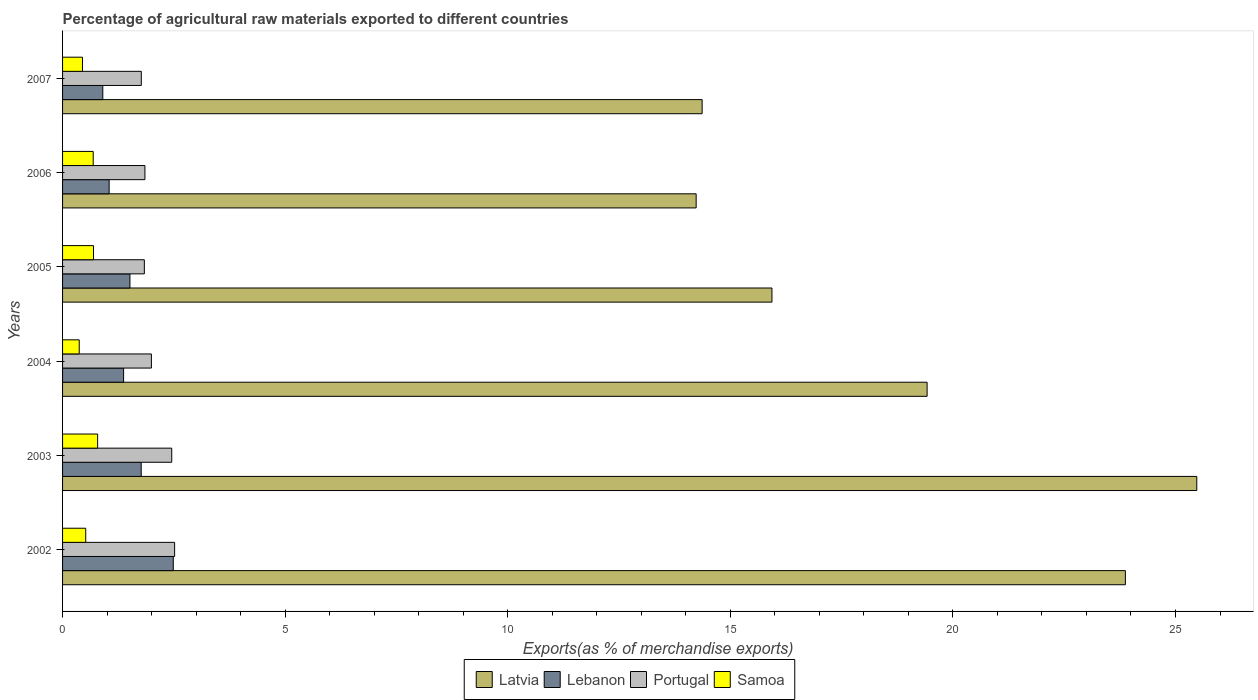How many groups of bars are there?
Your response must be concise. 6. Are the number of bars per tick equal to the number of legend labels?
Provide a succinct answer. Yes. Are the number of bars on each tick of the Y-axis equal?
Make the answer very short. Yes. How many bars are there on the 6th tick from the top?
Your answer should be compact. 4. In how many cases, is the number of bars for a given year not equal to the number of legend labels?
Provide a succinct answer. 0. What is the percentage of exports to different countries in Latvia in 2003?
Offer a terse response. 25.48. Across all years, what is the maximum percentage of exports to different countries in Samoa?
Provide a succinct answer. 0.79. Across all years, what is the minimum percentage of exports to different countries in Lebanon?
Offer a very short reply. 0.9. In which year was the percentage of exports to different countries in Samoa minimum?
Your response must be concise. 2004. What is the total percentage of exports to different countries in Latvia in the graph?
Make the answer very short. 113.31. What is the difference between the percentage of exports to different countries in Latvia in 2002 and that in 2003?
Offer a terse response. -1.6. What is the difference between the percentage of exports to different countries in Samoa in 2004 and the percentage of exports to different countries in Portugal in 2005?
Make the answer very short. -1.46. What is the average percentage of exports to different countries in Latvia per year?
Ensure brevity in your answer.  18.88. In the year 2003, what is the difference between the percentage of exports to different countries in Portugal and percentage of exports to different countries in Lebanon?
Offer a terse response. 0.69. What is the ratio of the percentage of exports to different countries in Samoa in 2003 to that in 2004?
Your answer should be very brief. 2.11. What is the difference between the highest and the second highest percentage of exports to different countries in Portugal?
Offer a terse response. 0.06. What is the difference between the highest and the lowest percentage of exports to different countries in Lebanon?
Provide a succinct answer. 1.58. In how many years, is the percentage of exports to different countries in Portugal greater than the average percentage of exports to different countries in Portugal taken over all years?
Offer a terse response. 2. What does the 2nd bar from the bottom in 2007 represents?
Provide a short and direct response. Lebanon. Is it the case that in every year, the sum of the percentage of exports to different countries in Portugal and percentage of exports to different countries in Latvia is greater than the percentage of exports to different countries in Lebanon?
Provide a short and direct response. Yes. How many bars are there?
Offer a very short reply. 24. Are all the bars in the graph horizontal?
Provide a short and direct response. Yes. What is the difference between two consecutive major ticks on the X-axis?
Provide a short and direct response. 5. Does the graph contain grids?
Your response must be concise. No. Where does the legend appear in the graph?
Provide a short and direct response. Bottom center. How many legend labels are there?
Offer a terse response. 4. How are the legend labels stacked?
Ensure brevity in your answer.  Horizontal. What is the title of the graph?
Ensure brevity in your answer.  Percentage of agricultural raw materials exported to different countries. Does "Ecuador" appear as one of the legend labels in the graph?
Your response must be concise. No. What is the label or title of the X-axis?
Provide a short and direct response. Exports(as % of merchandise exports). What is the label or title of the Y-axis?
Offer a very short reply. Years. What is the Exports(as % of merchandise exports) in Latvia in 2002?
Your answer should be compact. 23.87. What is the Exports(as % of merchandise exports) of Lebanon in 2002?
Your answer should be very brief. 2.49. What is the Exports(as % of merchandise exports) in Portugal in 2002?
Your response must be concise. 2.52. What is the Exports(as % of merchandise exports) of Samoa in 2002?
Offer a very short reply. 0.52. What is the Exports(as % of merchandise exports) in Latvia in 2003?
Provide a succinct answer. 25.48. What is the Exports(as % of merchandise exports) of Lebanon in 2003?
Make the answer very short. 1.77. What is the Exports(as % of merchandise exports) in Portugal in 2003?
Ensure brevity in your answer.  2.45. What is the Exports(as % of merchandise exports) of Samoa in 2003?
Your answer should be very brief. 0.79. What is the Exports(as % of merchandise exports) of Latvia in 2004?
Offer a terse response. 19.42. What is the Exports(as % of merchandise exports) in Lebanon in 2004?
Give a very brief answer. 1.37. What is the Exports(as % of merchandise exports) in Portugal in 2004?
Make the answer very short. 2. What is the Exports(as % of merchandise exports) of Samoa in 2004?
Your answer should be compact. 0.37. What is the Exports(as % of merchandise exports) in Latvia in 2005?
Provide a succinct answer. 15.94. What is the Exports(as % of merchandise exports) of Lebanon in 2005?
Provide a succinct answer. 1.51. What is the Exports(as % of merchandise exports) in Portugal in 2005?
Provide a succinct answer. 1.84. What is the Exports(as % of merchandise exports) in Samoa in 2005?
Your answer should be compact. 0.69. What is the Exports(as % of merchandise exports) in Latvia in 2006?
Provide a succinct answer. 14.23. What is the Exports(as % of merchandise exports) in Lebanon in 2006?
Ensure brevity in your answer.  1.05. What is the Exports(as % of merchandise exports) in Portugal in 2006?
Provide a short and direct response. 1.85. What is the Exports(as % of merchandise exports) of Samoa in 2006?
Ensure brevity in your answer.  0.69. What is the Exports(as % of merchandise exports) in Latvia in 2007?
Your answer should be very brief. 14.37. What is the Exports(as % of merchandise exports) of Lebanon in 2007?
Provide a short and direct response. 0.9. What is the Exports(as % of merchandise exports) in Portugal in 2007?
Ensure brevity in your answer.  1.77. What is the Exports(as % of merchandise exports) of Samoa in 2007?
Offer a very short reply. 0.45. Across all years, what is the maximum Exports(as % of merchandise exports) of Latvia?
Provide a short and direct response. 25.48. Across all years, what is the maximum Exports(as % of merchandise exports) of Lebanon?
Keep it short and to the point. 2.49. Across all years, what is the maximum Exports(as % of merchandise exports) in Portugal?
Your answer should be compact. 2.52. Across all years, what is the maximum Exports(as % of merchandise exports) of Samoa?
Your response must be concise. 0.79. Across all years, what is the minimum Exports(as % of merchandise exports) in Latvia?
Provide a short and direct response. 14.23. Across all years, what is the minimum Exports(as % of merchandise exports) in Lebanon?
Ensure brevity in your answer.  0.9. Across all years, what is the minimum Exports(as % of merchandise exports) in Portugal?
Ensure brevity in your answer.  1.77. Across all years, what is the minimum Exports(as % of merchandise exports) in Samoa?
Provide a succinct answer. 0.37. What is the total Exports(as % of merchandise exports) of Latvia in the graph?
Make the answer very short. 113.31. What is the total Exports(as % of merchandise exports) of Lebanon in the graph?
Your response must be concise. 9.09. What is the total Exports(as % of merchandise exports) in Portugal in the graph?
Provide a succinct answer. 12.42. What is the total Exports(as % of merchandise exports) of Samoa in the graph?
Offer a very short reply. 3.51. What is the difference between the Exports(as % of merchandise exports) of Latvia in 2002 and that in 2003?
Provide a short and direct response. -1.6. What is the difference between the Exports(as % of merchandise exports) of Lebanon in 2002 and that in 2003?
Provide a short and direct response. 0.72. What is the difference between the Exports(as % of merchandise exports) in Portugal in 2002 and that in 2003?
Your answer should be very brief. 0.07. What is the difference between the Exports(as % of merchandise exports) in Samoa in 2002 and that in 2003?
Ensure brevity in your answer.  -0.27. What is the difference between the Exports(as % of merchandise exports) of Latvia in 2002 and that in 2004?
Keep it short and to the point. 4.45. What is the difference between the Exports(as % of merchandise exports) of Lebanon in 2002 and that in 2004?
Keep it short and to the point. 1.12. What is the difference between the Exports(as % of merchandise exports) of Portugal in 2002 and that in 2004?
Provide a short and direct response. 0.52. What is the difference between the Exports(as % of merchandise exports) of Samoa in 2002 and that in 2004?
Provide a short and direct response. 0.15. What is the difference between the Exports(as % of merchandise exports) of Latvia in 2002 and that in 2005?
Your answer should be compact. 7.94. What is the difference between the Exports(as % of merchandise exports) of Lebanon in 2002 and that in 2005?
Make the answer very short. 0.97. What is the difference between the Exports(as % of merchandise exports) in Portugal in 2002 and that in 2005?
Your response must be concise. 0.68. What is the difference between the Exports(as % of merchandise exports) of Samoa in 2002 and that in 2005?
Your answer should be very brief. -0.17. What is the difference between the Exports(as % of merchandise exports) in Latvia in 2002 and that in 2006?
Provide a succinct answer. 9.64. What is the difference between the Exports(as % of merchandise exports) in Lebanon in 2002 and that in 2006?
Ensure brevity in your answer.  1.44. What is the difference between the Exports(as % of merchandise exports) of Portugal in 2002 and that in 2006?
Your answer should be very brief. 0.67. What is the difference between the Exports(as % of merchandise exports) of Samoa in 2002 and that in 2006?
Offer a terse response. -0.17. What is the difference between the Exports(as % of merchandise exports) of Latvia in 2002 and that in 2007?
Keep it short and to the point. 9.51. What is the difference between the Exports(as % of merchandise exports) in Lebanon in 2002 and that in 2007?
Your answer should be very brief. 1.58. What is the difference between the Exports(as % of merchandise exports) of Portugal in 2002 and that in 2007?
Keep it short and to the point. 0.75. What is the difference between the Exports(as % of merchandise exports) in Samoa in 2002 and that in 2007?
Keep it short and to the point. 0.07. What is the difference between the Exports(as % of merchandise exports) in Latvia in 2003 and that in 2004?
Offer a very short reply. 6.06. What is the difference between the Exports(as % of merchandise exports) of Lebanon in 2003 and that in 2004?
Ensure brevity in your answer.  0.4. What is the difference between the Exports(as % of merchandise exports) in Portugal in 2003 and that in 2004?
Keep it short and to the point. 0.46. What is the difference between the Exports(as % of merchandise exports) in Samoa in 2003 and that in 2004?
Offer a terse response. 0.41. What is the difference between the Exports(as % of merchandise exports) in Latvia in 2003 and that in 2005?
Your answer should be very brief. 9.54. What is the difference between the Exports(as % of merchandise exports) of Lebanon in 2003 and that in 2005?
Provide a short and direct response. 0.25. What is the difference between the Exports(as % of merchandise exports) of Portugal in 2003 and that in 2005?
Provide a short and direct response. 0.62. What is the difference between the Exports(as % of merchandise exports) of Samoa in 2003 and that in 2005?
Offer a terse response. 0.09. What is the difference between the Exports(as % of merchandise exports) in Latvia in 2003 and that in 2006?
Offer a very short reply. 11.25. What is the difference between the Exports(as % of merchandise exports) in Lebanon in 2003 and that in 2006?
Provide a succinct answer. 0.72. What is the difference between the Exports(as % of merchandise exports) of Portugal in 2003 and that in 2006?
Offer a very short reply. 0.6. What is the difference between the Exports(as % of merchandise exports) of Samoa in 2003 and that in 2006?
Provide a short and direct response. 0.1. What is the difference between the Exports(as % of merchandise exports) of Latvia in 2003 and that in 2007?
Ensure brevity in your answer.  11.11. What is the difference between the Exports(as % of merchandise exports) of Lebanon in 2003 and that in 2007?
Provide a short and direct response. 0.86. What is the difference between the Exports(as % of merchandise exports) of Portugal in 2003 and that in 2007?
Your answer should be very brief. 0.68. What is the difference between the Exports(as % of merchandise exports) in Samoa in 2003 and that in 2007?
Ensure brevity in your answer.  0.34. What is the difference between the Exports(as % of merchandise exports) in Latvia in 2004 and that in 2005?
Give a very brief answer. 3.49. What is the difference between the Exports(as % of merchandise exports) in Lebanon in 2004 and that in 2005?
Ensure brevity in your answer.  -0.14. What is the difference between the Exports(as % of merchandise exports) of Portugal in 2004 and that in 2005?
Make the answer very short. 0.16. What is the difference between the Exports(as % of merchandise exports) in Samoa in 2004 and that in 2005?
Your answer should be compact. -0.32. What is the difference between the Exports(as % of merchandise exports) in Latvia in 2004 and that in 2006?
Provide a short and direct response. 5.19. What is the difference between the Exports(as % of merchandise exports) in Lebanon in 2004 and that in 2006?
Offer a very short reply. 0.33. What is the difference between the Exports(as % of merchandise exports) of Portugal in 2004 and that in 2006?
Provide a short and direct response. 0.15. What is the difference between the Exports(as % of merchandise exports) of Samoa in 2004 and that in 2006?
Keep it short and to the point. -0.31. What is the difference between the Exports(as % of merchandise exports) of Latvia in 2004 and that in 2007?
Keep it short and to the point. 5.05. What is the difference between the Exports(as % of merchandise exports) of Lebanon in 2004 and that in 2007?
Ensure brevity in your answer.  0.47. What is the difference between the Exports(as % of merchandise exports) in Portugal in 2004 and that in 2007?
Offer a terse response. 0.23. What is the difference between the Exports(as % of merchandise exports) in Samoa in 2004 and that in 2007?
Provide a short and direct response. -0.07. What is the difference between the Exports(as % of merchandise exports) of Latvia in 2005 and that in 2006?
Your answer should be compact. 1.7. What is the difference between the Exports(as % of merchandise exports) of Lebanon in 2005 and that in 2006?
Your response must be concise. 0.47. What is the difference between the Exports(as % of merchandise exports) in Portugal in 2005 and that in 2006?
Keep it short and to the point. -0.01. What is the difference between the Exports(as % of merchandise exports) of Samoa in 2005 and that in 2006?
Your response must be concise. 0.01. What is the difference between the Exports(as % of merchandise exports) of Latvia in 2005 and that in 2007?
Your response must be concise. 1.57. What is the difference between the Exports(as % of merchandise exports) in Lebanon in 2005 and that in 2007?
Provide a succinct answer. 0.61. What is the difference between the Exports(as % of merchandise exports) in Portugal in 2005 and that in 2007?
Offer a very short reply. 0.07. What is the difference between the Exports(as % of merchandise exports) in Samoa in 2005 and that in 2007?
Ensure brevity in your answer.  0.25. What is the difference between the Exports(as % of merchandise exports) in Latvia in 2006 and that in 2007?
Your response must be concise. -0.13. What is the difference between the Exports(as % of merchandise exports) in Lebanon in 2006 and that in 2007?
Provide a short and direct response. 0.14. What is the difference between the Exports(as % of merchandise exports) of Portugal in 2006 and that in 2007?
Keep it short and to the point. 0.08. What is the difference between the Exports(as % of merchandise exports) in Samoa in 2006 and that in 2007?
Your answer should be compact. 0.24. What is the difference between the Exports(as % of merchandise exports) in Latvia in 2002 and the Exports(as % of merchandise exports) in Lebanon in 2003?
Give a very brief answer. 22.11. What is the difference between the Exports(as % of merchandise exports) of Latvia in 2002 and the Exports(as % of merchandise exports) of Portugal in 2003?
Provide a short and direct response. 21.42. What is the difference between the Exports(as % of merchandise exports) of Latvia in 2002 and the Exports(as % of merchandise exports) of Samoa in 2003?
Ensure brevity in your answer.  23.09. What is the difference between the Exports(as % of merchandise exports) of Lebanon in 2002 and the Exports(as % of merchandise exports) of Portugal in 2003?
Keep it short and to the point. 0.03. What is the difference between the Exports(as % of merchandise exports) in Lebanon in 2002 and the Exports(as % of merchandise exports) in Samoa in 2003?
Provide a succinct answer. 1.7. What is the difference between the Exports(as % of merchandise exports) in Portugal in 2002 and the Exports(as % of merchandise exports) in Samoa in 2003?
Your response must be concise. 1.73. What is the difference between the Exports(as % of merchandise exports) of Latvia in 2002 and the Exports(as % of merchandise exports) of Lebanon in 2004?
Provide a short and direct response. 22.5. What is the difference between the Exports(as % of merchandise exports) of Latvia in 2002 and the Exports(as % of merchandise exports) of Portugal in 2004?
Your response must be concise. 21.88. What is the difference between the Exports(as % of merchandise exports) of Latvia in 2002 and the Exports(as % of merchandise exports) of Samoa in 2004?
Ensure brevity in your answer.  23.5. What is the difference between the Exports(as % of merchandise exports) of Lebanon in 2002 and the Exports(as % of merchandise exports) of Portugal in 2004?
Provide a succinct answer. 0.49. What is the difference between the Exports(as % of merchandise exports) in Lebanon in 2002 and the Exports(as % of merchandise exports) in Samoa in 2004?
Your answer should be very brief. 2.11. What is the difference between the Exports(as % of merchandise exports) of Portugal in 2002 and the Exports(as % of merchandise exports) of Samoa in 2004?
Offer a terse response. 2.14. What is the difference between the Exports(as % of merchandise exports) of Latvia in 2002 and the Exports(as % of merchandise exports) of Lebanon in 2005?
Keep it short and to the point. 22.36. What is the difference between the Exports(as % of merchandise exports) of Latvia in 2002 and the Exports(as % of merchandise exports) of Portugal in 2005?
Provide a short and direct response. 22.04. What is the difference between the Exports(as % of merchandise exports) in Latvia in 2002 and the Exports(as % of merchandise exports) in Samoa in 2005?
Offer a very short reply. 23.18. What is the difference between the Exports(as % of merchandise exports) in Lebanon in 2002 and the Exports(as % of merchandise exports) in Portugal in 2005?
Provide a short and direct response. 0.65. What is the difference between the Exports(as % of merchandise exports) in Lebanon in 2002 and the Exports(as % of merchandise exports) in Samoa in 2005?
Make the answer very short. 1.79. What is the difference between the Exports(as % of merchandise exports) in Portugal in 2002 and the Exports(as % of merchandise exports) in Samoa in 2005?
Offer a terse response. 1.82. What is the difference between the Exports(as % of merchandise exports) of Latvia in 2002 and the Exports(as % of merchandise exports) of Lebanon in 2006?
Keep it short and to the point. 22.83. What is the difference between the Exports(as % of merchandise exports) in Latvia in 2002 and the Exports(as % of merchandise exports) in Portugal in 2006?
Provide a succinct answer. 22.02. What is the difference between the Exports(as % of merchandise exports) in Latvia in 2002 and the Exports(as % of merchandise exports) in Samoa in 2006?
Your response must be concise. 23.19. What is the difference between the Exports(as % of merchandise exports) of Lebanon in 2002 and the Exports(as % of merchandise exports) of Portugal in 2006?
Keep it short and to the point. 0.64. What is the difference between the Exports(as % of merchandise exports) of Lebanon in 2002 and the Exports(as % of merchandise exports) of Samoa in 2006?
Make the answer very short. 1.8. What is the difference between the Exports(as % of merchandise exports) of Portugal in 2002 and the Exports(as % of merchandise exports) of Samoa in 2006?
Your response must be concise. 1.83. What is the difference between the Exports(as % of merchandise exports) of Latvia in 2002 and the Exports(as % of merchandise exports) of Lebanon in 2007?
Keep it short and to the point. 22.97. What is the difference between the Exports(as % of merchandise exports) in Latvia in 2002 and the Exports(as % of merchandise exports) in Portugal in 2007?
Ensure brevity in your answer.  22.11. What is the difference between the Exports(as % of merchandise exports) in Latvia in 2002 and the Exports(as % of merchandise exports) in Samoa in 2007?
Give a very brief answer. 23.43. What is the difference between the Exports(as % of merchandise exports) of Lebanon in 2002 and the Exports(as % of merchandise exports) of Portugal in 2007?
Your answer should be very brief. 0.72. What is the difference between the Exports(as % of merchandise exports) in Lebanon in 2002 and the Exports(as % of merchandise exports) in Samoa in 2007?
Make the answer very short. 2.04. What is the difference between the Exports(as % of merchandise exports) of Portugal in 2002 and the Exports(as % of merchandise exports) of Samoa in 2007?
Your answer should be very brief. 2.07. What is the difference between the Exports(as % of merchandise exports) in Latvia in 2003 and the Exports(as % of merchandise exports) in Lebanon in 2004?
Make the answer very short. 24.11. What is the difference between the Exports(as % of merchandise exports) in Latvia in 2003 and the Exports(as % of merchandise exports) in Portugal in 2004?
Ensure brevity in your answer.  23.48. What is the difference between the Exports(as % of merchandise exports) in Latvia in 2003 and the Exports(as % of merchandise exports) in Samoa in 2004?
Offer a terse response. 25.1. What is the difference between the Exports(as % of merchandise exports) of Lebanon in 2003 and the Exports(as % of merchandise exports) of Portugal in 2004?
Your response must be concise. -0.23. What is the difference between the Exports(as % of merchandise exports) of Lebanon in 2003 and the Exports(as % of merchandise exports) of Samoa in 2004?
Your answer should be compact. 1.39. What is the difference between the Exports(as % of merchandise exports) in Portugal in 2003 and the Exports(as % of merchandise exports) in Samoa in 2004?
Offer a very short reply. 2.08. What is the difference between the Exports(as % of merchandise exports) in Latvia in 2003 and the Exports(as % of merchandise exports) in Lebanon in 2005?
Your answer should be compact. 23.97. What is the difference between the Exports(as % of merchandise exports) of Latvia in 2003 and the Exports(as % of merchandise exports) of Portugal in 2005?
Your response must be concise. 23.64. What is the difference between the Exports(as % of merchandise exports) of Latvia in 2003 and the Exports(as % of merchandise exports) of Samoa in 2005?
Give a very brief answer. 24.78. What is the difference between the Exports(as % of merchandise exports) in Lebanon in 2003 and the Exports(as % of merchandise exports) in Portugal in 2005?
Offer a very short reply. -0.07. What is the difference between the Exports(as % of merchandise exports) of Lebanon in 2003 and the Exports(as % of merchandise exports) of Samoa in 2005?
Offer a very short reply. 1.07. What is the difference between the Exports(as % of merchandise exports) in Portugal in 2003 and the Exports(as % of merchandise exports) in Samoa in 2005?
Provide a short and direct response. 1.76. What is the difference between the Exports(as % of merchandise exports) of Latvia in 2003 and the Exports(as % of merchandise exports) of Lebanon in 2006?
Your answer should be compact. 24.43. What is the difference between the Exports(as % of merchandise exports) in Latvia in 2003 and the Exports(as % of merchandise exports) in Portugal in 2006?
Make the answer very short. 23.63. What is the difference between the Exports(as % of merchandise exports) in Latvia in 2003 and the Exports(as % of merchandise exports) in Samoa in 2006?
Ensure brevity in your answer.  24.79. What is the difference between the Exports(as % of merchandise exports) in Lebanon in 2003 and the Exports(as % of merchandise exports) in Portugal in 2006?
Your response must be concise. -0.08. What is the difference between the Exports(as % of merchandise exports) of Lebanon in 2003 and the Exports(as % of merchandise exports) of Samoa in 2006?
Your response must be concise. 1.08. What is the difference between the Exports(as % of merchandise exports) of Portugal in 2003 and the Exports(as % of merchandise exports) of Samoa in 2006?
Offer a terse response. 1.76. What is the difference between the Exports(as % of merchandise exports) in Latvia in 2003 and the Exports(as % of merchandise exports) in Lebanon in 2007?
Your answer should be compact. 24.57. What is the difference between the Exports(as % of merchandise exports) in Latvia in 2003 and the Exports(as % of merchandise exports) in Portugal in 2007?
Ensure brevity in your answer.  23.71. What is the difference between the Exports(as % of merchandise exports) in Latvia in 2003 and the Exports(as % of merchandise exports) in Samoa in 2007?
Offer a terse response. 25.03. What is the difference between the Exports(as % of merchandise exports) of Lebanon in 2003 and the Exports(as % of merchandise exports) of Portugal in 2007?
Make the answer very short. -0. What is the difference between the Exports(as % of merchandise exports) of Lebanon in 2003 and the Exports(as % of merchandise exports) of Samoa in 2007?
Ensure brevity in your answer.  1.32. What is the difference between the Exports(as % of merchandise exports) of Portugal in 2003 and the Exports(as % of merchandise exports) of Samoa in 2007?
Your response must be concise. 2. What is the difference between the Exports(as % of merchandise exports) of Latvia in 2004 and the Exports(as % of merchandise exports) of Lebanon in 2005?
Your response must be concise. 17.91. What is the difference between the Exports(as % of merchandise exports) of Latvia in 2004 and the Exports(as % of merchandise exports) of Portugal in 2005?
Keep it short and to the point. 17.58. What is the difference between the Exports(as % of merchandise exports) of Latvia in 2004 and the Exports(as % of merchandise exports) of Samoa in 2005?
Your answer should be very brief. 18.73. What is the difference between the Exports(as % of merchandise exports) of Lebanon in 2004 and the Exports(as % of merchandise exports) of Portugal in 2005?
Your response must be concise. -0.47. What is the difference between the Exports(as % of merchandise exports) in Lebanon in 2004 and the Exports(as % of merchandise exports) in Samoa in 2005?
Keep it short and to the point. 0.68. What is the difference between the Exports(as % of merchandise exports) of Portugal in 2004 and the Exports(as % of merchandise exports) of Samoa in 2005?
Your response must be concise. 1.3. What is the difference between the Exports(as % of merchandise exports) of Latvia in 2004 and the Exports(as % of merchandise exports) of Lebanon in 2006?
Provide a short and direct response. 18.37. What is the difference between the Exports(as % of merchandise exports) in Latvia in 2004 and the Exports(as % of merchandise exports) in Portugal in 2006?
Your response must be concise. 17.57. What is the difference between the Exports(as % of merchandise exports) in Latvia in 2004 and the Exports(as % of merchandise exports) in Samoa in 2006?
Your answer should be very brief. 18.73. What is the difference between the Exports(as % of merchandise exports) of Lebanon in 2004 and the Exports(as % of merchandise exports) of Portugal in 2006?
Your answer should be very brief. -0.48. What is the difference between the Exports(as % of merchandise exports) in Lebanon in 2004 and the Exports(as % of merchandise exports) in Samoa in 2006?
Give a very brief answer. 0.68. What is the difference between the Exports(as % of merchandise exports) in Portugal in 2004 and the Exports(as % of merchandise exports) in Samoa in 2006?
Offer a terse response. 1.31. What is the difference between the Exports(as % of merchandise exports) in Latvia in 2004 and the Exports(as % of merchandise exports) in Lebanon in 2007?
Keep it short and to the point. 18.52. What is the difference between the Exports(as % of merchandise exports) of Latvia in 2004 and the Exports(as % of merchandise exports) of Portugal in 2007?
Provide a short and direct response. 17.65. What is the difference between the Exports(as % of merchandise exports) of Latvia in 2004 and the Exports(as % of merchandise exports) of Samoa in 2007?
Your answer should be very brief. 18.97. What is the difference between the Exports(as % of merchandise exports) in Lebanon in 2004 and the Exports(as % of merchandise exports) in Portugal in 2007?
Offer a very short reply. -0.4. What is the difference between the Exports(as % of merchandise exports) in Lebanon in 2004 and the Exports(as % of merchandise exports) in Samoa in 2007?
Make the answer very short. 0.92. What is the difference between the Exports(as % of merchandise exports) of Portugal in 2004 and the Exports(as % of merchandise exports) of Samoa in 2007?
Provide a short and direct response. 1.55. What is the difference between the Exports(as % of merchandise exports) of Latvia in 2005 and the Exports(as % of merchandise exports) of Lebanon in 2006?
Give a very brief answer. 14.89. What is the difference between the Exports(as % of merchandise exports) of Latvia in 2005 and the Exports(as % of merchandise exports) of Portugal in 2006?
Provide a short and direct response. 14.09. What is the difference between the Exports(as % of merchandise exports) in Latvia in 2005 and the Exports(as % of merchandise exports) in Samoa in 2006?
Ensure brevity in your answer.  15.25. What is the difference between the Exports(as % of merchandise exports) in Lebanon in 2005 and the Exports(as % of merchandise exports) in Portugal in 2006?
Your answer should be very brief. -0.34. What is the difference between the Exports(as % of merchandise exports) in Lebanon in 2005 and the Exports(as % of merchandise exports) in Samoa in 2006?
Offer a very short reply. 0.83. What is the difference between the Exports(as % of merchandise exports) of Portugal in 2005 and the Exports(as % of merchandise exports) of Samoa in 2006?
Make the answer very short. 1.15. What is the difference between the Exports(as % of merchandise exports) in Latvia in 2005 and the Exports(as % of merchandise exports) in Lebanon in 2007?
Ensure brevity in your answer.  15.03. What is the difference between the Exports(as % of merchandise exports) of Latvia in 2005 and the Exports(as % of merchandise exports) of Portugal in 2007?
Offer a very short reply. 14.17. What is the difference between the Exports(as % of merchandise exports) of Latvia in 2005 and the Exports(as % of merchandise exports) of Samoa in 2007?
Keep it short and to the point. 15.49. What is the difference between the Exports(as % of merchandise exports) in Lebanon in 2005 and the Exports(as % of merchandise exports) in Portugal in 2007?
Ensure brevity in your answer.  -0.26. What is the difference between the Exports(as % of merchandise exports) in Lebanon in 2005 and the Exports(as % of merchandise exports) in Samoa in 2007?
Offer a terse response. 1.07. What is the difference between the Exports(as % of merchandise exports) in Portugal in 2005 and the Exports(as % of merchandise exports) in Samoa in 2007?
Keep it short and to the point. 1.39. What is the difference between the Exports(as % of merchandise exports) of Latvia in 2006 and the Exports(as % of merchandise exports) of Lebanon in 2007?
Offer a terse response. 13.33. What is the difference between the Exports(as % of merchandise exports) in Latvia in 2006 and the Exports(as % of merchandise exports) in Portugal in 2007?
Provide a short and direct response. 12.46. What is the difference between the Exports(as % of merchandise exports) of Latvia in 2006 and the Exports(as % of merchandise exports) of Samoa in 2007?
Your answer should be compact. 13.78. What is the difference between the Exports(as % of merchandise exports) in Lebanon in 2006 and the Exports(as % of merchandise exports) in Portugal in 2007?
Your answer should be compact. -0.72. What is the difference between the Exports(as % of merchandise exports) of Lebanon in 2006 and the Exports(as % of merchandise exports) of Samoa in 2007?
Give a very brief answer. 0.6. What is the difference between the Exports(as % of merchandise exports) of Portugal in 2006 and the Exports(as % of merchandise exports) of Samoa in 2007?
Your response must be concise. 1.4. What is the average Exports(as % of merchandise exports) of Latvia per year?
Provide a succinct answer. 18.88. What is the average Exports(as % of merchandise exports) of Lebanon per year?
Offer a very short reply. 1.51. What is the average Exports(as % of merchandise exports) in Portugal per year?
Offer a terse response. 2.07. What is the average Exports(as % of merchandise exports) in Samoa per year?
Your response must be concise. 0.59. In the year 2002, what is the difference between the Exports(as % of merchandise exports) in Latvia and Exports(as % of merchandise exports) in Lebanon?
Provide a succinct answer. 21.39. In the year 2002, what is the difference between the Exports(as % of merchandise exports) in Latvia and Exports(as % of merchandise exports) in Portugal?
Provide a succinct answer. 21.36. In the year 2002, what is the difference between the Exports(as % of merchandise exports) of Latvia and Exports(as % of merchandise exports) of Samoa?
Your answer should be very brief. 23.35. In the year 2002, what is the difference between the Exports(as % of merchandise exports) in Lebanon and Exports(as % of merchandise exports) in Portugal?
Make the answer very short. -0.03. In the year 2002, what is the difference between the Exports(as % of merchandise exports) in Lebanon and Exports(as % of merchandise exports) in Samoa?
Your response must be concise. 1.97. In the year 2002, what is the difference between the Exports(as % of merchandise exports) in Portugal and Exports(as % of merchandise exports) in Samoa?
Offer a very short reply. 2. In the year 2003, what is the difference between the Exports(as % of merchandise exports) of Latvia and Exports(as % of merchandise exports) of Lebanon?
Keep it short and to the point. 23.71. In the year 2003, what is the difference between the Exports(as % of merchandise exports) in Latvia and Exports(as % of merchandise exports) in Portugal?
Provide a succinct answer. 23.03. In the year 2003, what is the difference between the Exports(as % of merchandise exports) of Latvia and Exports(as % of merchandise exports) of Samoa?
Your response must be concise. 24.69. In the year 2003, what is the difference between the Exports(as % of merchandise exports) in Lebanon and Exports(as % of merchandise exports) in Portugal?
Your response must be concise. -0.69. In the year 2003, what is the difference between the Exports(as % of merchandise exports) of Lebanon and Exports(as % of merchandise exports) of Samoa?
Make the answer very short. 0.98. In the year 2003, what is the difference between the Exports(as % of merchandise exports) of Portugal and Exports(as % of merchandise exports) of Samoa?
Keep it short and to the point. 1.66. In the year 2004, what is the difference between the Exports(as % of merchandise exports) of Latvia and Exports(as % of merchandise exports) of Lebanon?
Ensure brevity in your answer.  18.05. In the year 2004, what is the difference between the Exports(as % of merchandise exports) in Latvia and Exports(as % of merchandise exports) in Portugal?
Your answer should be very brief. 17.43. In the year 2004, what is the difference between the Exports(as % of merchandise exports) in Latvia and Exports(as % of merchandise exports) in Samoa?
Your answer should be very brief. 19.05. In the year 2004, what is the difference between the Exports(as % of merchandise exports) in Lebanon and Exports(as % of merchandise exports) in Portugal?
Make the answer very short. -0.62. In the year 2004, what is the difference between the Exports(as % of merchandise exports) in Portugal and Exports(as % of merchandise exports) in Samoa?
Your answer should be compact. 1.62. In the year 2005, what is the difference between the Exports(as % of merchandise exports) of Latvia and Exports(as % of merchandise exports) of Lebanon?
Your answer should be very brief. 14.42. In the year 2005, what is the difference between the Exports(as % of merchandise exports) of Latvia and Exports(as % of merchandise exports) of Portugal?
Your answer should be compact. 14.1. In the year 2005, what is the difference between the Exports(as % of merchandise exports) in Latvia and Exports(as % of merchandise exports) in Samoa?
Make the answer very short. 15.24. In the year 2005, what is the difference between the Exports(as % of merchandise exports) of Lebanon and Exports(as % of merchandise exports) of Portugal?
Keep it short and to the point. -0.32. In the year 2005, what is the difference between the Exports(as % of merchandise exports) in Lebanon and Exports(as % of merchandise exports) in Samoa?
Provide a short and direct response. 0.82. In the year 2005, what is the difference between the Exports(as % of merchandise exports) in Portugal and Exports(as % of merchandise exports) in Samoa?
Your answer should be very brief. 1.14. In the year 2006, what is the difference between the Exports(as % of merchandise exports) of Latvia and Exports(as % of merchandise exports) of Lebanon?
Your answer should be compact. 13.19. In the year 2006, what is the difference between the Exports(as % of merchandise exports) in Latvia and Exports(as % of merchandise exports) in Portugal?
Ensure brevity in your answer.  12.38. In the year 2006, what is the difference between the Exports(as % of merchandise exports) in Latvia and Exports(as % of merchandise exports) in Samoa?
Provide a succinct answer. 13.54. In the year 2006, what is the difference between the Exports(as % of merchandise exports) of Lebanon and Exports(as % of merchandise exports) of Portugal?
Offer a terse response. -0.8. In the year 2006, what is the difference between the Exports(as % of merchandise exports) of Lebanon and Exports(as % of merchandise exports) of Samoa?
Offer a terse response. 0.36. In the year 2006, what is the difference between the Exports(as % of merchandise exports) of Portugal and Exports(as % of merchandise exports) of Samoa?
Give a very brief answer. 1.16. In the year 2007, what is the difference between the Exports(as % of merchandise exports) in Latvia and Exports(as % of merchandise exports) in Lebanon?
Offer a very short reply. 13.46. In the year 2007, what is the difference between the Exports(as % of merchandise exports) in Latvia and Exports(as % of merchandise exports) in Portugal?
Provide a short and direct response. 12.6. In the year 2007, what is the difference between the Exports(as % of merchandise exports) in Latvia and Exports(as % of merchandise exports) in Samoa?
Provide a short and direct response. 13.92. In the year 2007, what is the difference between the Exports(as % of merchandise exports) in Lebanon and Exports(as % of merchandise exports) in Portugal?
Make the answer very short. -0.86. In the year 2007, what is the difference between the Exports(as % of merchandise exports) of Lebanon and Exports(as % of merchandise exports) of Samoa?
Give a very brief answer. 0.46. In the year 2007, what is the difference between the Exports(as % of merchandise exports) in Portugal and Exports(as % of merchandise exports) in Samoa?
Your answer should be very brief. 1.32. What is the ratio of the Exports(as % of merchandise exports) of Latvia in 2002 to that in 2003?
Give a very brief answer. 0.94. What is the ratio of the Exports(as % of merchandise exports) of Lebanon in 2002 to that in 2003?
Make the answer very short. 1.41. What is the ratio of the Exports(as % of merchandise exports) of Portugal in 2002 to that in 2003?
Give a very brief answer. 1.03. What is the ratio of the Exports(as % of merchandise exports) in Samoa in 2002 to that in 2003?
Offer a very short reply. 0.66. What is the ratio of the Exports(as % of merchandise exports) of Latvia in 2002 to that in 2004?
Offer a very short reply. 1.23. What is the ratio of the Exports(as % of merchandise exports) of Lebanon in 2002 to that in 2004?
Give a very brief answer. 1.81. What is the ratio of the Exports(as % of merchandise exports) of Portugal in 2002 to that in 2004?
Provide a succinct answer. 1.26. What is the ratio of the Exports(as % of merchandise exports) in Samoa in 2002 to that in 2004?
Keep it short and to the point. 1.39. What is the ratio of the Exports(as % of merchandise exports) in Latvia in 2002 to that in 2005?
Provide a succinct answer. 1.5. What is the ratio of the Exports(as % of merchandise exports) of Lebanon in 2002 to that in 2005?
Keep it short and to the point. 1.64. What is the ratio of the Exports(as % of merchandise exports) of Portugal in 2002 to that in 2005?
Your answer should be very brief. 1.37. What is the ratio of the Exports(as % of merchandise exports) of Samoa in 2002 to that in 2005?
Provide a succinct answer. 0.75. What is the ratio of the Exports(as % of merchandise exports) of Latvia in 2002 to that in 2006?
Your response must be concise. 1.68. What is the ratio of the Exports(as % of merchandise exports) in Lebanon in 2002 to that in 2006?
Give a very brief answer. 2.38. What is the ratio of the Exports(as % of merchandise exports) of Portugal in 2002 to that in 2006?
Ensure brevity in your answer.  1.36. What is the ratio of the Exports(as % of merchandise exports) of Samoa in 2002 to that in 2006?
Keep it short and to the point. 0.76. What is the ratio of the Exports(as % of merchandise exports) in Latvia in 2002 to that in 2007?
Provide a succinct answer. 1.66. What is the ratio of the Exports(as % of merchandise exports) in Lebanon in 2002 to that in 2007?
Provide a short and direct response. 2.75. What is the ratio of the Exports(as % of merchandise exports) in Portugal in 2002 to that in 2007?
Your answer should be very brief. 1.42. What is the ratio of the Exports(as % of merchandise exports) of Samoa in 2002 to that in 2007?
Offer a very short reply. 1.16. What is the ratio of the Exports(as % of merchandise exports) in Latvia in 2003 to that in 2004?
Offer a very short reply. 1.31. What is the ratio of the Exports(as % of merchandise exports) in Lebanon in 2003 to that in 2004?
Your answer should be compact. 1.29. What is the ratio of the Exports(as % of merchandise exports) of Portugal in 2003 to that in 2004?
Provide a succinct answer. 1.23. What is the ratio of the Exports(as % of merchandise exports) of Samoa in 2003 to that in 2004?
Give a very brief answer. 2.11. What is the ratio of the Exports(as % of merchandise exports) of Latvia in 2003 to that in 2005?
Make the answer very short. 1.6. What is the ratio of the Exports(as % of merchandise exports) in Lebanon in 2003 to that in 2005?
Give a very brief answer. 1.17. What is the ratio of the Exports(as % of merchandise exports) of Portugal in 2003 to that in 2005?
Your answer should be very brief. 1.33. What is the ratio of the Exports(as % of merchandise exports) in Samoa in 2003 to that in 2005?
Give a very brief answer. 1.13. What is the ratio of the Exports(as % of merchandise exports) of Latvia in 2003 to that in 2006?
Offer a very short reply. 1.79. What is the ratio of the Exports(as % of merchandise exports) of Lebanon in 2003 to that in 2006?
Keep it short and to the point. 1.69. What is the ratio of the Exports(as % of merchandise exports) in Portugal in 2003 to that in 2006?
Give a very brief answer. 1.33. What is the ratio of the Exports(as % of merchandise exports) in Samoa in 2003 to that in 2006?
Offer a terse response. 1.14. What is the ratio of the Exports(as % of merchandise exports) in Latvia in 2003 to that in 2007?
Your response must be concise. 1.77. What is the ratio of the Exports(as % of merchandise exports) of Lebanon in 2003 to that in 2007?
Keep it short and to the point. 1.95. What is the ratio of the Exports(as % of merchandise exports) of Portugal in 2003 to that in 2007?
Give a very brief answer. 1.39. What is the ratio of the Exports(as % of merchandise exports) in Samoa in 2003 to that in 2007?
Your answer should be very brief. 1.76. What is the ratio of the Exports(as % of merchandise exports) of Latvia in 2004 to that in 2005?
Give a very brief answer. 1.22. What is the ratio of the Exports(as % of merchandise exports) in Lebanon in 2004 to that in 2005?
Make the answer very short. 0.91. What is the ratio of the Exports(as % of merchandise exports) of Portugal in 2004 to that in 2005?
Offer a terse response. 1.09. What is the ratio of the Exports(as % of merchandise exports) in Samoa in 2004 to that in 2005?
Offer a terse response. 0.54. What is the ratio of the Exports(as % of merchandise exports) of Latvia in 2004 to that in 2006?
Provide a short and direct response. 1.36. What is the ratio of the Exports(as % of merchandise exports) in Lebanon in 2004 to that in 2006?
Give a very brief answer. 1.31. What is the ratio of the Exports(as % of merchandise exports) in Portugal in 2004 to that in 2006?
Your answer should be very brief. 1.08. What is the ratio of the Exports(as % of merchandise exports) in Samoa in 2004 to that in 2006?
Provide a succinct answer. 0.54. What is the ratio of the Exports(as % of merchandise exports) of Latvia in 2004 to that in 2007?
Provide a succinct answer. 1.35. What is the ratio of the Exports(as % of merchandise exports) in Lebanon in 2004 to that in 2007?
Offer a terse response. 1.52. What is the ratio of the Exports(as % of merchandise exports) in Portugal in 2004 to that in 2007?
Offer a very short reply. 1.13. What is the ratio of the Exports(as % of merchandise exports) of Samoa in 2004 to that in 2007?
Your answer should be very brief. 0.84. What is the ratio of the Exports(as % of merchandise exports) in Latvia in 2005 to that in 2006?
Ensure brevity in your answer.  1.12. What is the ratio of the Exports(as % of merchandise exports) of Lebanon in 2005 to that in 2006?
Make the answer very short. 1.45. What is the ratio of the Exports(as % of merchandise exports) in Portugal in 2005 to that in 2006?
Provide a succinct answer. 0.99. What is the ratio of the Exports(as % of merchandise exports) of Samoa in 2005 to that in 2006?
Make the answer very short. 1.01. What is the ratio of the Exports(as % of merchandise exports) of Latvia in 2005 to that in 2007?
Keep it short and to the point. 1.11. What is the ratio of the Exports(as % of merchandise exports) of Lebanon in 2005 to that in 2007?
Offer a terse response. 1.67. What is the ratio of the Exports(as % of merchandise exports) of Portugal in 2005 to that in 2007?
Provide a short and direct response. 1.04. What is the ratio of the Exports(as % of merchandise exports) of Samoa in 2005 to that in 2007?
Provide a succinct answer. 1.55. What is the ratio of the Exports(as % of merchandise exports) of Latvia in 2006 to that in 2007?
Ensure brevity in your answer.  0.99. What is the ratio of the Exports(as % of merchandise exports) of Lebanon in 2006 to that in 2007?
Your answer should be compact. 1.16. What is the ratio of the Exports(as % of merchandise exports) of Portugal in 2006 to that in 2007?
Your response must be concise. 1.05. What is the ratio of the Exports(as % of merchandise exports) of Samoa in 2006 to that in 2007?
Your response must be concise. 1.54. What is the difference between the highest and the second highest Exports(as % of merchandise exports) of Latvia?
Your response must be concise. 1.6. What is the difference between the highest and the second highest Exports(as % of merchandise exports) of Lebanon?
Offer a terse response. 0.72. What is the difference between the highest and the second highest Exports(as % of merchandise exports) of Portugal?
Provide a succinct answer. 0.07. What is the difference between the highest and the second highest Exports(as % of merchandise exports) of Samoa?
Offer a terse response. 0.09. What is the difference between the highest and the lowest Exports(as % of merchandise exports) in Latvia?
Ensure brevity in your answer.  11.25. What is the difference between the highest and the lowest Exports(as % of merchandise exports) in Lebanon?
Offer a very short reply. 1.58. What is the difference between the highest and the lowest Exports(as % of merchandise exports) of Portugal?
Provide a succinct answer. 0.75. What is the difference between the highest and the lowest Exports(as % of merchandise exports) of Samoa?
Provide a short and direct response. 0.41. 